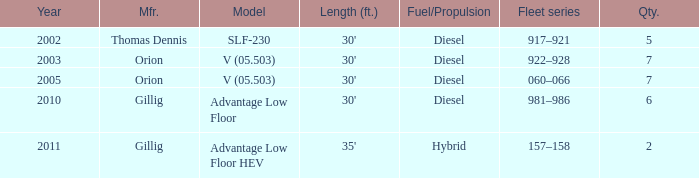Name the sum of quantity for before 2011 model slf-230 5.0. Could you help me parse every detail presented in this table? {'header': ['Year', 'Mfr.', 'Model', 'Length (ft.)', 'Fuel/Propulsion', 'Fleet series', 'Qty.'], 'rows': [['2002', 'Thomas Dennis', 'SLF-230', "30'", 'Diesel', '917–921', '5'], ['2003', 'Orion', 'V (05.503)', "30'", 'Diesel', '922–928', '7'], ['2005', 'Orion', 'V (05.503)', "30'", 'Diesel', '060–066', '7'], ['2010', 'Gillig', 'Advantage Low Floor', "30'", 'Diesel', '981–986', '6'], ['2011', 'Gillig', 'Advantage Low Floor HEV', "35'", 'Hybrid', '157–158', '2']]} 